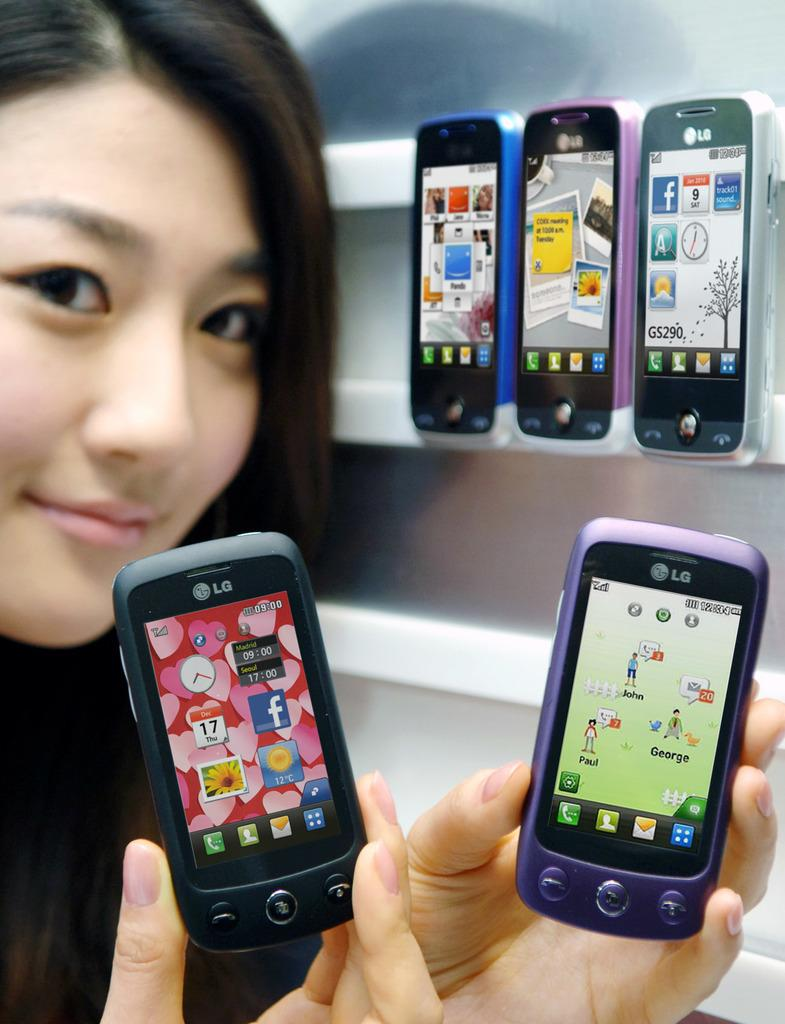<image>
Relay a brief, clear account of the picture shown. A person is smiling and holding two different LG phones in their hands. 